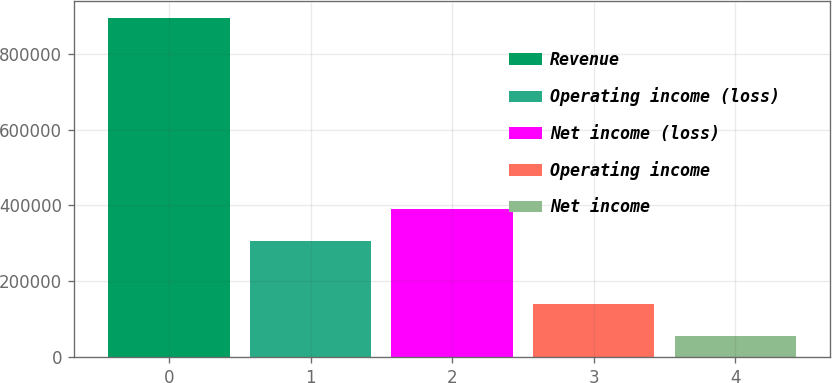Convert chart. <chart><loc_0><loc_0><loc_500><loc_500><bar_chart><fcel>Revenue<fcel>Operating income (loss)<fcel>Net income (loss)<fcel>Operating income<fcel>Net income<nl><fcel>894725<fcel>307133<fcel>391159<fcel>138494<fcel>54468<nl></chart> 